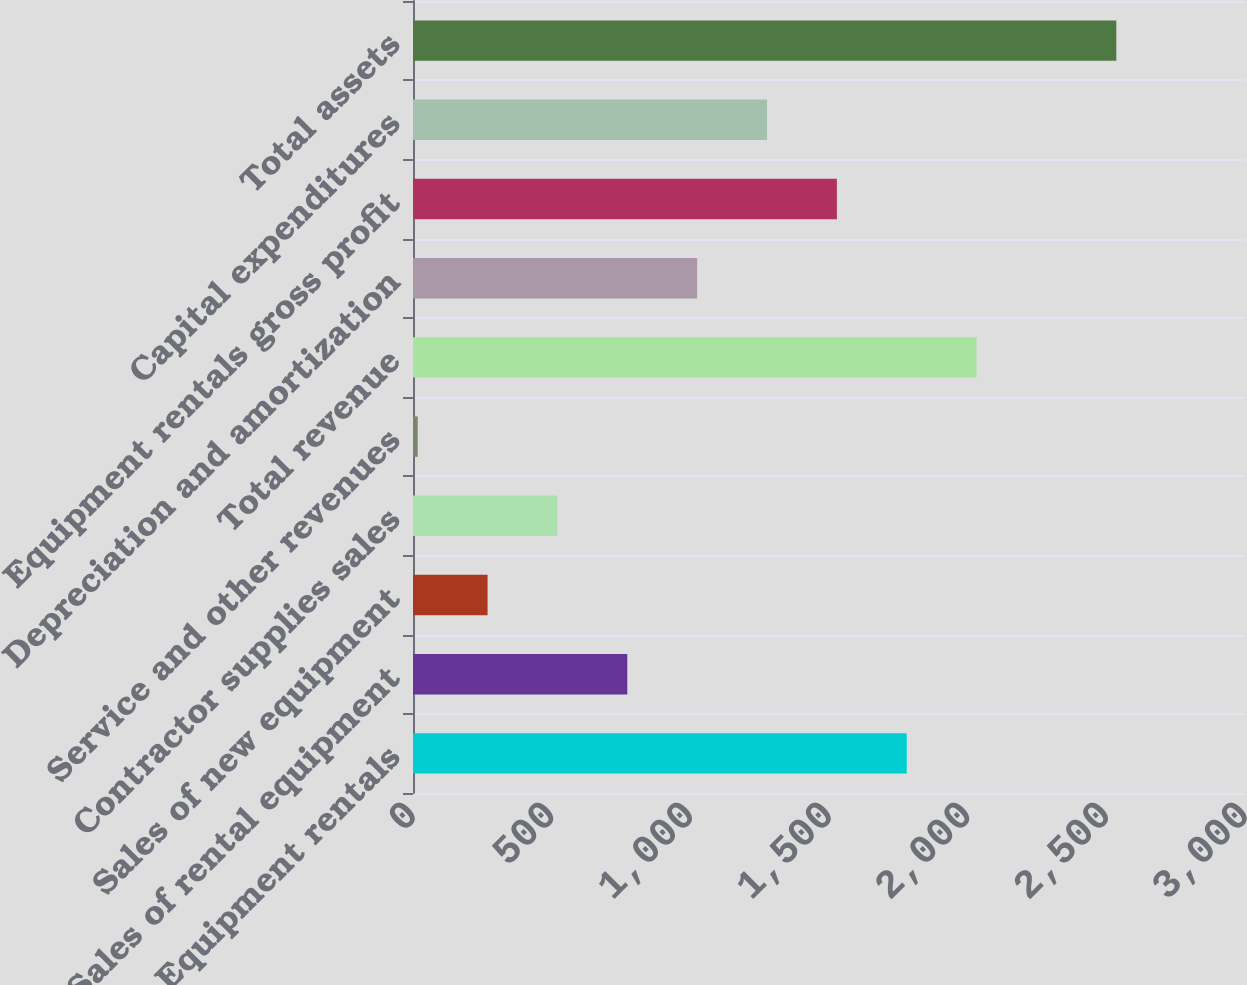Convert chart. <chart><loc_0><loc_0><loc_500><loc_500><bar_chart><fcel>Equipment rentals<fcel>Sales of rental equipment<fcel>Sales of new equipment<fcel>Contractor supplies sales<fcel>Service and other revenues<fcel>Total revenue<fcel>Depreciation and amortization<fcel>Equipment rentals gross profit<fcel>Capital expenditures<fcel>Total assets<nl><fcel>1780.3<fcel>772.7<fcel>268.9<fcel>520.8<fcel>17<fcel>2032.2<fcel>1024.6<fcel>1528.4<fcel>1276.5<fcel>2536<nl></chart> 